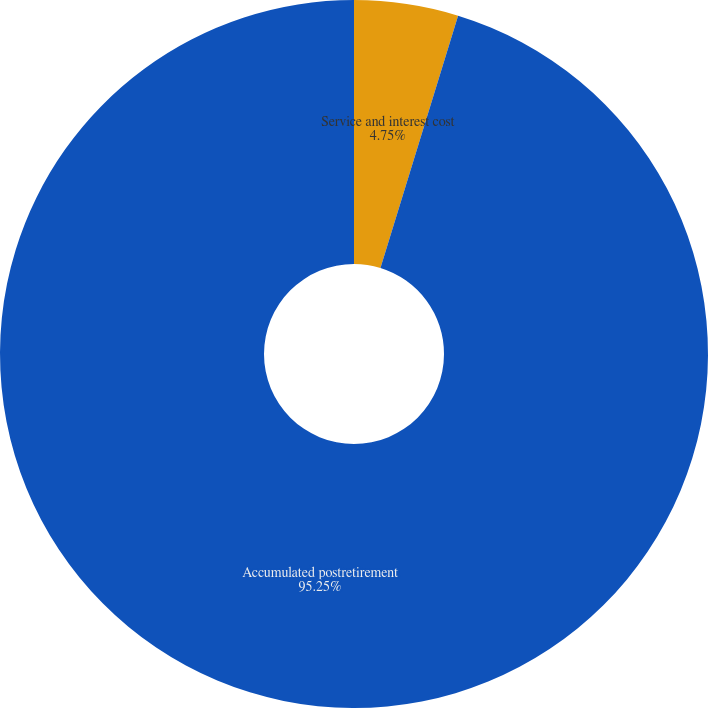Convert chart. <chart><loc_0><loc_0><loc_500><loc_500><pie_chart><fcel>Service and interest cost<fcel>Accumulated postretirement<nl><fcel>4.75%<fcel>95.25%<nl></chart> 